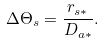Convert formula to latex. <formula><loc_0><loc_0><loc_500><loc_500>\Delta \Theta _ { s } = \frac { r _ { s * } } { D _ { a * } } .</formula> 